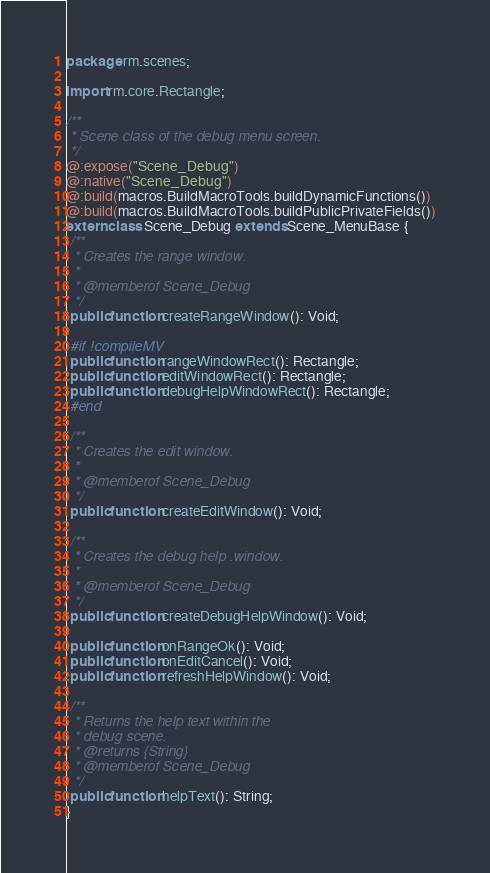Convert code to text. <code><loc_0><loc_0><loc_500><loc_500><_Haxe_>package rm.scenes;

import rm.core.Rectangle;

/**
 * Scene class of the debug menu screen.
 */
@:expose("Scene_Debug")
@:native("Scene_Debug")
@:build(macros.BuildMacroTools.buildDynamicFunctions())
@:build(macros.BuildMacroTools.buildPublicPrivateFields())
extern class Scene_Debug extends Scene_MenuBase {
 /**
  * Creates the range window.
  *
  * @memberof Scene_Debug
  */
 public function createRangeWindow(): Void;

 #if !compileMV
 public function rangeWindowRect(): Rectangle;
 public function editWindowRect(): Rectangle;
 public function debugHelpWindowRect(): Rectangle;
 #end

 /**
  * Creates the edit window.
  *
  * @memberof Scene_Debug
  */
 public function createEditWindow(): Void;

 /**
  * Creates the debug help .window.
  *
  * @memberof Scene_Debug
  */
 public function createDebugHelpWindow(): Void;

 public function onRangeOk(): Void;
 public function onEditCancel(): Void;
 public function refreshHelpWindow(): Void;

 /**
  * Returns the help text within the
  * debug scene.
  * @returns {String}
  * @memberof Scene_Debug
  */
 public function helpText(): String;
}
</code> 